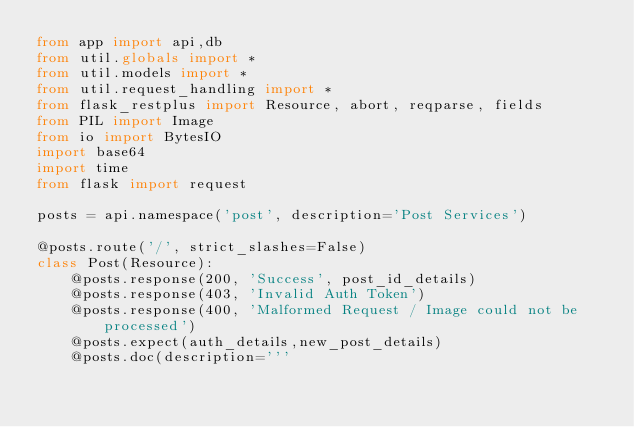Convert code to text. <code><loc_0><loc_0><loc_500><loc_500><_Python_>from app import api,db
from util.globals import *
from util.models import *
from util.request_handling import *
from flask_restplus import Resource, abort, reqparse, fields
from PIL import Image
from io import BytesIO
import base64
import time
from flask import request

posts = api.namespace('post', description='Post Services')

@posts.route('/', strict_slashes=False)
class Post(Resource):
    @posts.response(200, 'Success', post_id_details)
    @posts.response(403, 'Invalid Auth Token')
    @posts.response(400, 'Malformed Request / Image could not be processed')
    @posts.expect(auth_details,new_post_details)
    @posts.doc(description='''</code> 